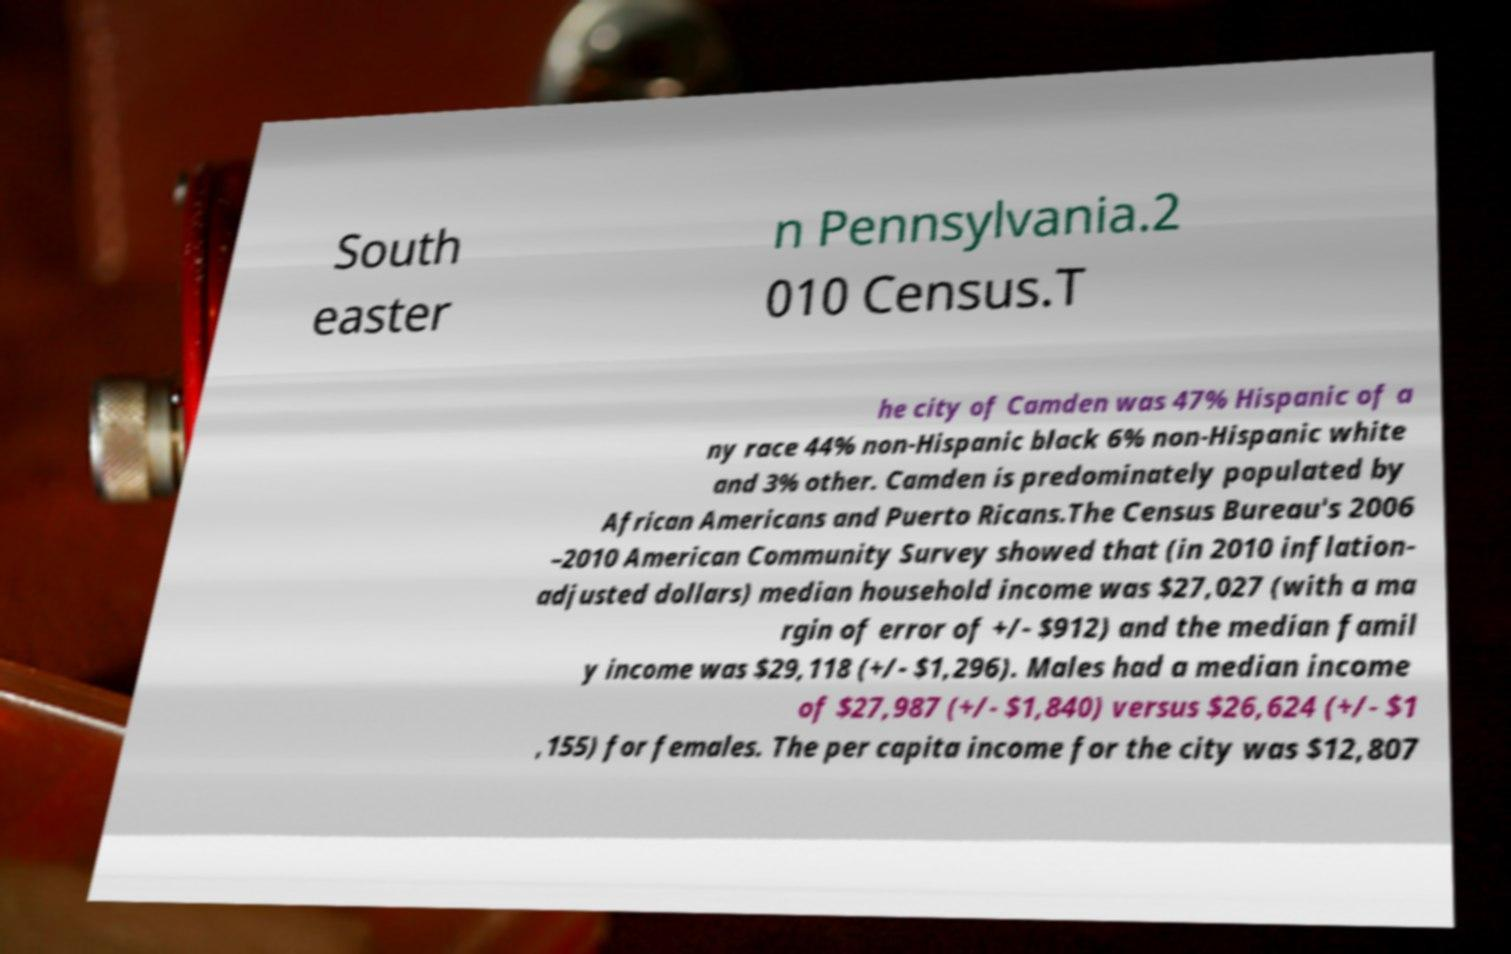Can you accurately transcribe the text from the provided image for me? South easter n Pennsylvania.2 010 Census.T he city of Camden was 47% Hispanic of a ny race 44% non-Hispanic black 6% non-Hispanic white and 3% other. Camden is predominately populated by African Americans and Puerto Ricans.The Census Bureau's 2006 –2010 American Community Survey showed that (in 2010 inflation- adjusted dollars) median household income was $27,027 (with a ma rgin of error of +/- $912) and the median famil y income was $29,118 (+/- $1,296). Males had a median income of $27,987 (+/- $1,840) versus $26,624 (+/- $1 ,155) for females. The per capita income for the city was $12,807 